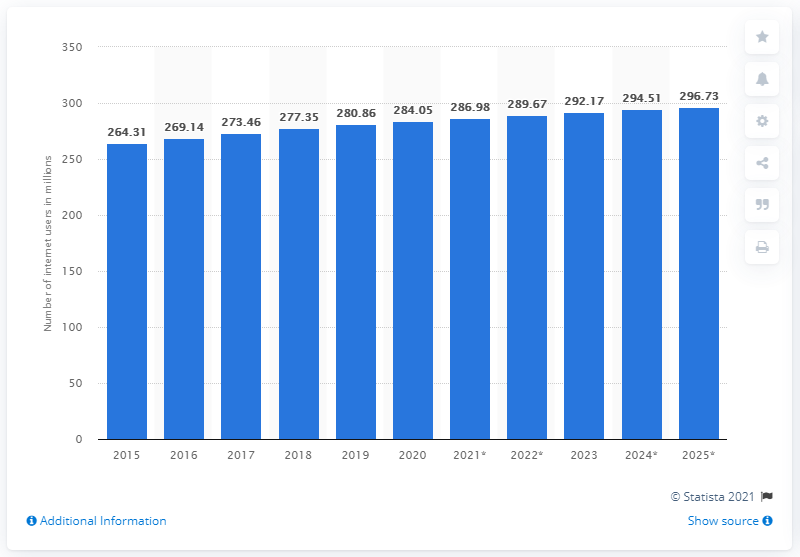Highlight a few significant elements in this photo. In 2020, there were 284.05 million internet users in the United States. By the end of 2025, it is projected that there will be approximately 296.73 million internet users in the United States. 